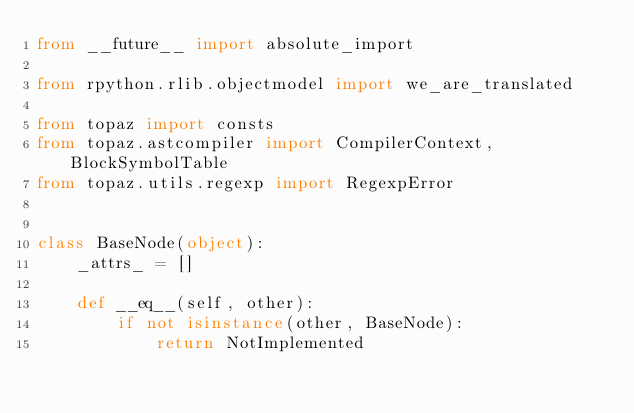<code> <loc_0><loc_0><loc_500><loc_500><_Python_>from __future__ import absolute_import

from rpython.rlib.objectmodel import we_are_translated

from topaz import consts
from topaz.astcompiler import CompilerContext, BlockSymbolTable
from topaz.utils.regexp import RegexpError


class BaseNode(object):
    _attrs_ = []

    def __eq__(self, other):
        if not isinstance(other, BaseNode):
            return NotImplemented</code> 